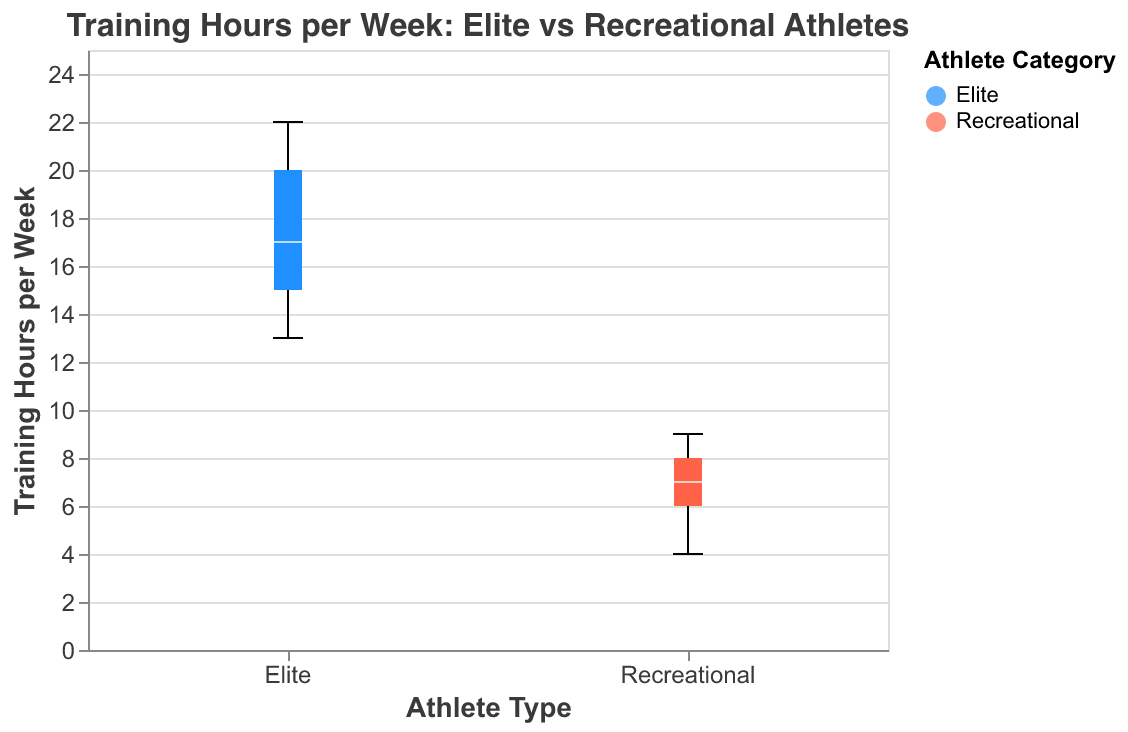How many data points are there for elite athletes? By counting the number of boxes representing the data points for elite athletes on the plot, we see there are 15 boxes.
Answer: 15 Which group has the higher median training hours per week? The median is represented by the white line inside each box. The elite athletes have a higher median training hours per week compared to recreational athletes.
Answer: Elite What is the range of training hours per week for recreational athletes? The range is found by subtracting the minimum value from the maximum value in the box plot for recreational athletes. The minimum value is 4 and the maximum is 9.
Answer: 5 What's the interquartile range (IQR) of training hours per week for elite athletes? The IQR is the range between the first quartile (Q1) and the third quartile (Q3). For elite athletes, Q1 is approximately 15 and Q3 is approximately 20, so IQR is 20 - 15.
Answer: 5 Which group has more variability in training hours per week? Variability is indicated by the spread of the boxes and whiskers in the plot. The elite athletes' group shows a greater spread from 13 to 22, indicating more variability compared to the recreational group.
Answer: Elite What is the maximum training hours per week for elite athletes? The maximum is indicated by the upper whisker of the elite athletes' box plot, which reaches 22 hours.
Answer: 22 What is the difference in the median training hours per week between elite and recreational athletes? The median training hours for elite athletes is around 17.5, and for recreational athletes, it is around 7. So, the difference is 17.5 - 7.
Answer: 10.5 Are there any outliers in either group? By looking at the plot, we can determine outliers if any point lies significantly outside the whiskers. Both groups’ box plots have whiskers extending to the min and max values without any outliers.
Answer: No What is the minimum training hours per week for recreational athletes? The minimum value is indicated by the lower whisker of the recreational athletes' box plot, which is 4 hours.
Answer: 4 How much more do elite athletes train on average compared to recreational athletes? By approximating the average from the plot, elite athletes train on average around 17.5 hours and recreational athletes around 7 hours. The difference is 17.5 - 7.
Answer: 10.5 